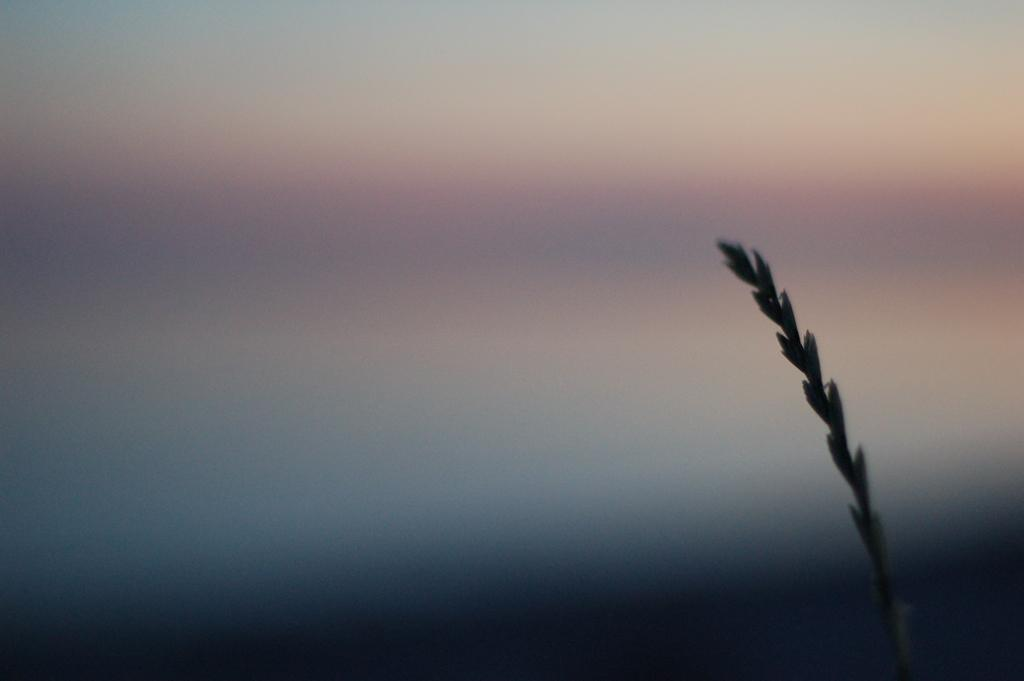What type of living organism can be seen in the image? There is a plant in the image. How many faucets are attached to the plant in the image? There are no faucets present in the image; it features a plant. What type of bikes can be seen near the plant in the image? There are no bikes present in the image; it features a plant. 